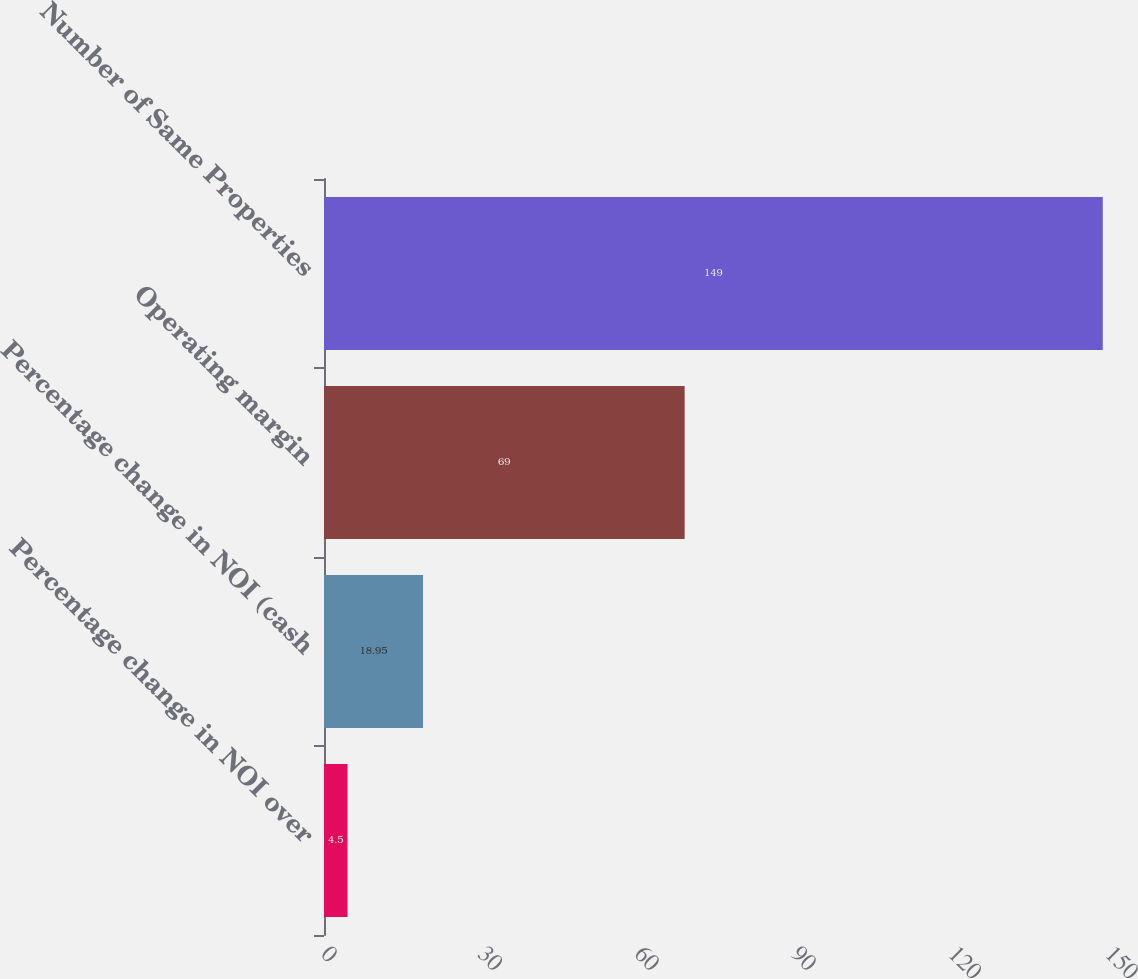Convert chart. <chart><loc_0><loc_0><loc_500><loc_500><bar_chart><fcel>Percentage change in NOI over<fcel>Percentage change in NOI (cash<fcel>Operating margin<fcel>Number of Same Properties<nl><fcel>4.5<fcel>18.95<fcel>69<fcel>149<nl></chart> 